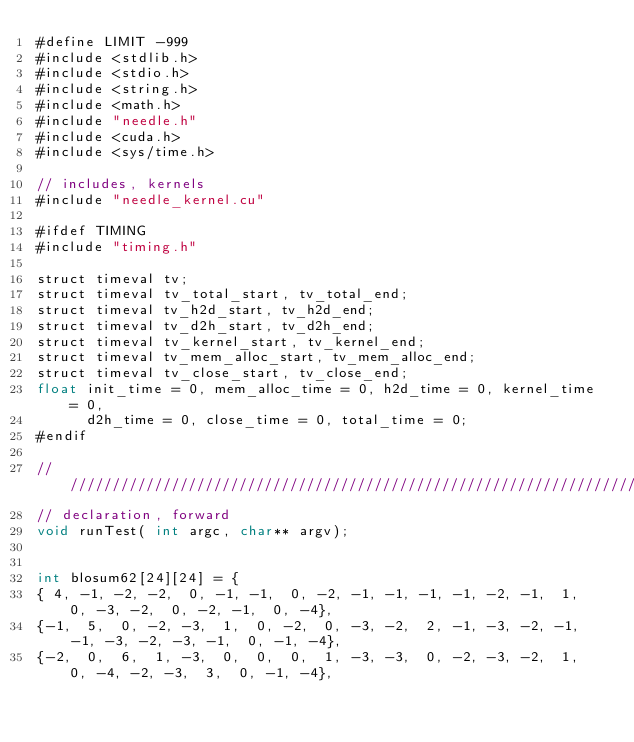<code> <loc_0><loc_0><loc_500><loc_500><_Cuda_>#define LIMIT -999
#include <stdlib.h>
#include <stdio.h>
#include <string.h>
#include <math.h>
#include "needle.h"
#include <cuda.h>
#include <sys/time.h>

// includes, kernels
#include "needle_kernel.cu"

#ifdef TIMING
#include "timing.h"

struct timeval tv;
struct timeval tv_total_start, tv_total_end;
struct timeval tv_h2d_start, tv_h2d_end;
struct timeval tv_d2h_start, tv_d2h_end;
struct timeval tv_kernel_start, tv_kernel_end;
struct timeval tv_mem_alloc_start, tv_mem_alloc_end;
struct timeval tv_close_start, tv_close_end;
float init_time = 0, mem_alloc_time = 0, h2d_time = 0, kernel_time = 0,
      d2h_time = 0, close_time = 0, total_time = 0;
#endif

////////////////////////////////////////////////////////////////////////////////
// declaration, forward
void runTest( int argc, char** argv);


int blosum62[24][24] = {
{ 4, -1, -2, -2,  0, -1, -1,  0, -2, -1, -1, -1, -1, -2, -1,  1,  0, -3, -2,  0, -2, -1,  0, -4},
{-1,  5,  0, -2, -3,  1,  0, -2,  0, -3, -2,  2, -1, -3, -2, -1, -1, -3, -2, -3, -1,  0, -1, -4},
{-2,  0,  6,  1, -3,  0,  0,  0,  1, -3, -3,  0, -2, -3, -2,  1,  0, -4, -2, -3,  3,  0, -1, -4},</code> 